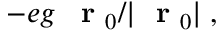<formula> <loc_0><loc_0><loc_500><loc_500>- e g \, r _ { 0 } / | r _ { 0 } | \, ,</formula> 